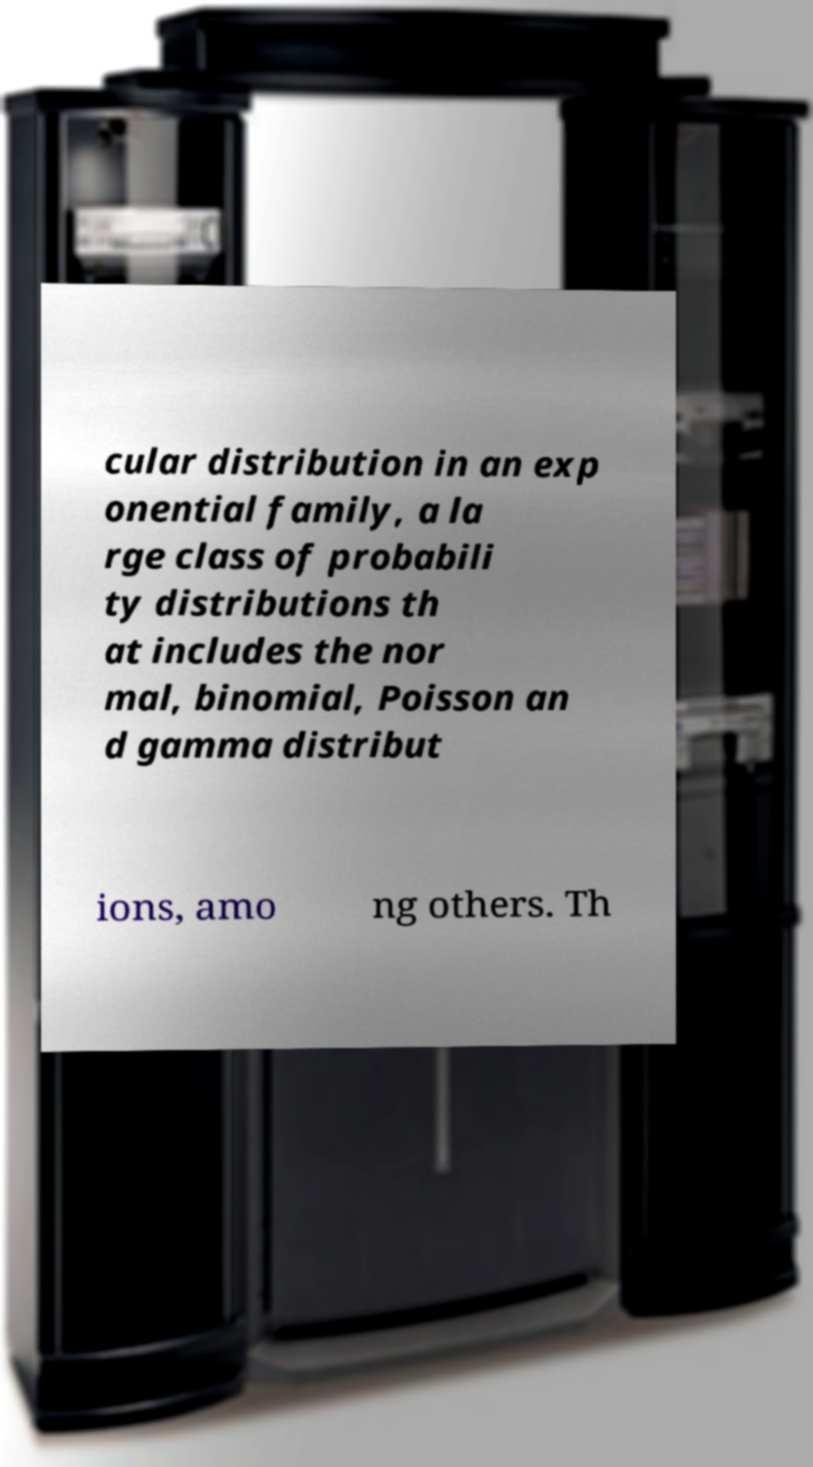For documentation purposes, I need the text within this image transcribed. Could you provide that? cular distribution in an exp onential family, a la rge class of probabili ty distributions th at includes the nor mal, binomial, Poisson an d gamma distribut ions, amo ng others. Th 